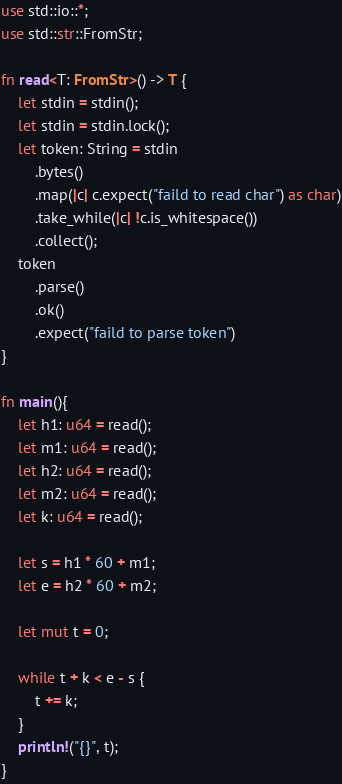<code> <loc_0><loc_0><loc_500><loc_500><_Rust_>use std::io::*;
use std::str::FromStr;

fn read<T: FromStr>() -> T {
    let stdin = stdin();
    let stdin = stdin.lock();
    let token: String = stdin
        .bytes()
        .map(|c| c.expect("faild to read char") as char)
        .take_while(|c| !c.is_whitespace())
        .collect();
    token
        .parse()
        .ok()
        .expect("faild to parse token")
}

fn main(){
    let h1: u64 = read();
    let m1: u64 = read();
    let h2: u64 = read();
    let m2: u64 = read();
    let k: u64 = read();

    let s = h1 * 60 + m1;
    let e = h2 * 60 + m2;

    let mut t = 0;

    while t + k < e - s {
        t += k;
    }
    println!("{}", t);
}
</code> 